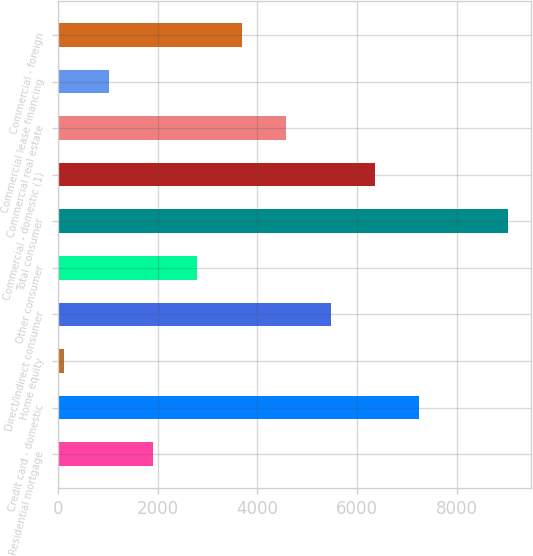Convert chart to OTSL. <chart><loc_0><loc_0><loc_500><loc_500><bar_chart><fcel>Residential mortgage<fcel>Credit card - domestic<fcel>Home equity<fcel>Direct/Indirect consumer<fcel>Other consumer<fcel>Total consumer<fcel>Commercial - domestic (1)<fcel>Commercial real estate<fcel>Commercial lease financing<fcel>Commercial - foreign<nl><fcel>1909.6<fcel>7239.4<fcel>133<fcel>5462.8<fcel>2797.9<fcel>9016<fcel>6351.1<fcel>4574.5<fcel>1021.3<fcel>3686.2<nl></chart> 